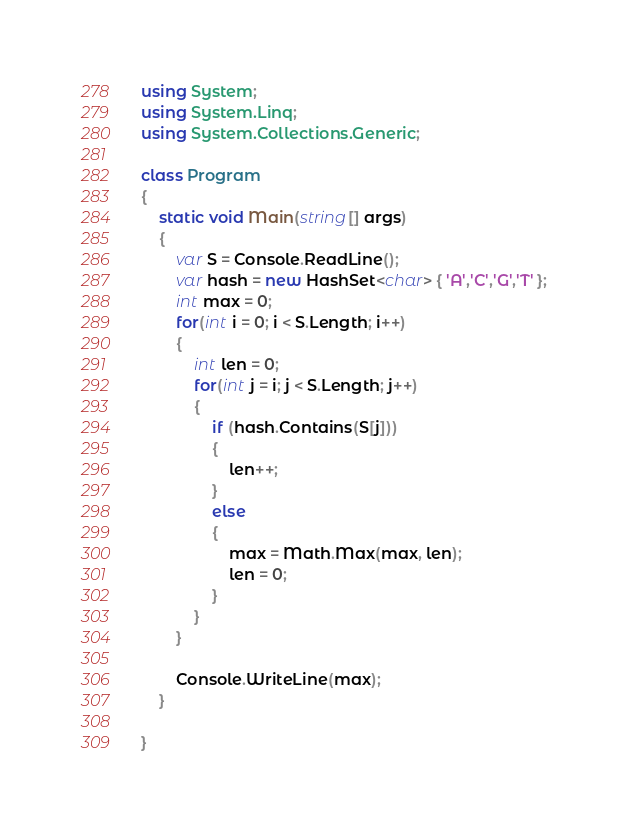<code> <loc_0><loc_0><loc_500><loc_500><_C#_>using System;
using System.Linq;
using System.Collections.Generic;

class Program
{
    static void Main(string[] args)
    {
        var S = Console.ReadLine();
        var hash = new HashSet<char> { 'A','C','G','T' };
        int max = 0;
        for(int i = 0; i < S.Length; i++)
        {
            int len = 0;
            for(int j = i; j < S.Length; j++)
            {
                if (hash.Contains(S[j]))
                {
                    len++;
                }
                else
                {
                    max = Math.Max(max, len);
                    len = 0;
                }
            }
        }

        Console.WriteLine(max);
    }

}

</code> 